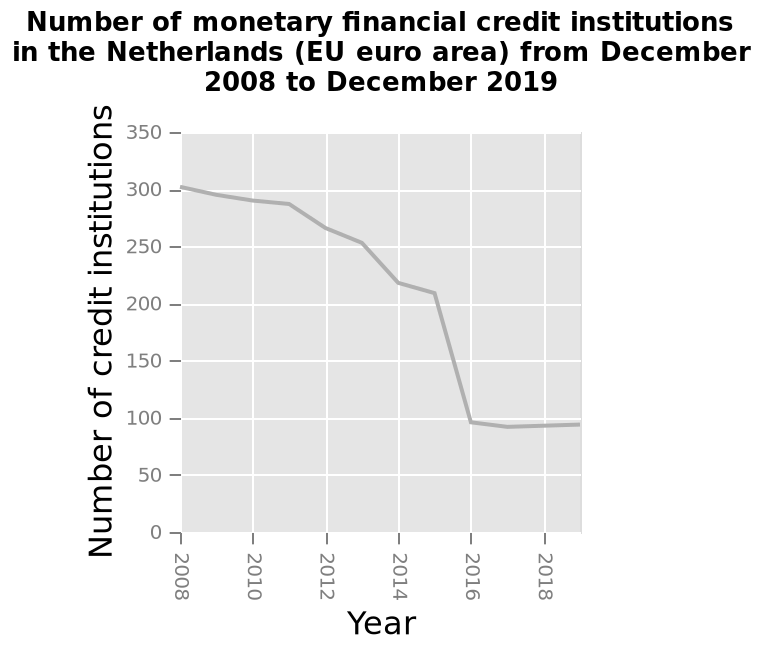<image>
Which country's credit institutions are represented in the diagram? The credit institutions of the Netherlands (EU euro area) are represented in the diagram. What happened to the number of financial institutions up to 2016?  The number of financial institutions decreased significantly. Describe the following image in detail This is a line diagram called Number of monetary financial credit institutions in the Netherlands (EU euro area) from December 2008 to December 2019. The x-axis shows Year while the y-axis plots Number of credit institutions. Over what time period does the line diagram cover? The line diagram covers the time period from December 2008 to December 2019. Did the number of financial institutions increase or decrease before 2016? The number of financial institutions decreased before 2016. please summary the statistics and relations of the chart THE NUMBER OF FINACIAL  INSTITUTIONS DECREASED SIGNIFICANTLY UP TO 2016 BUT HAS NOW STABILISED. Are the credit institutions of Brazil (non-EU euro area) represented in the diagram? No.The credit institutions of the Netherlands (EU euro area) are represented in the diagram. Is this a bar graph called Number of monetary financial credit institutions in the Netherlands (EU euro area) from August 2002 to December 2016? No.This is a line diagram called Number of monetary financial credit institutions in the Netherlands (EU euro area) from December 2008 to December 2019. The x-axis shows Year while the y-axis plots Number of credit institutions. 